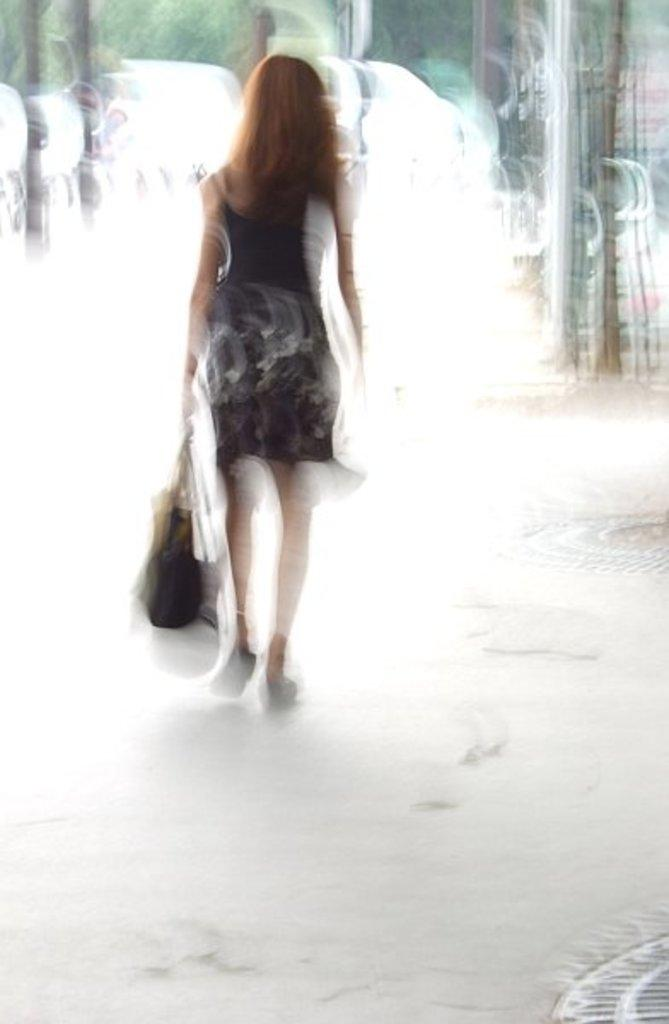Who is the main subject in the image? There is a woman in the image. What is the woman holding in the image? The woman is holding a bag. What is the woman doing in the image? The woman is walking. Can you describe the background of the image? The background of the image appears blurry. What type of smile can be seen on the water in the image? There is no water present in the image, and therefore no smile can be seen on it. 